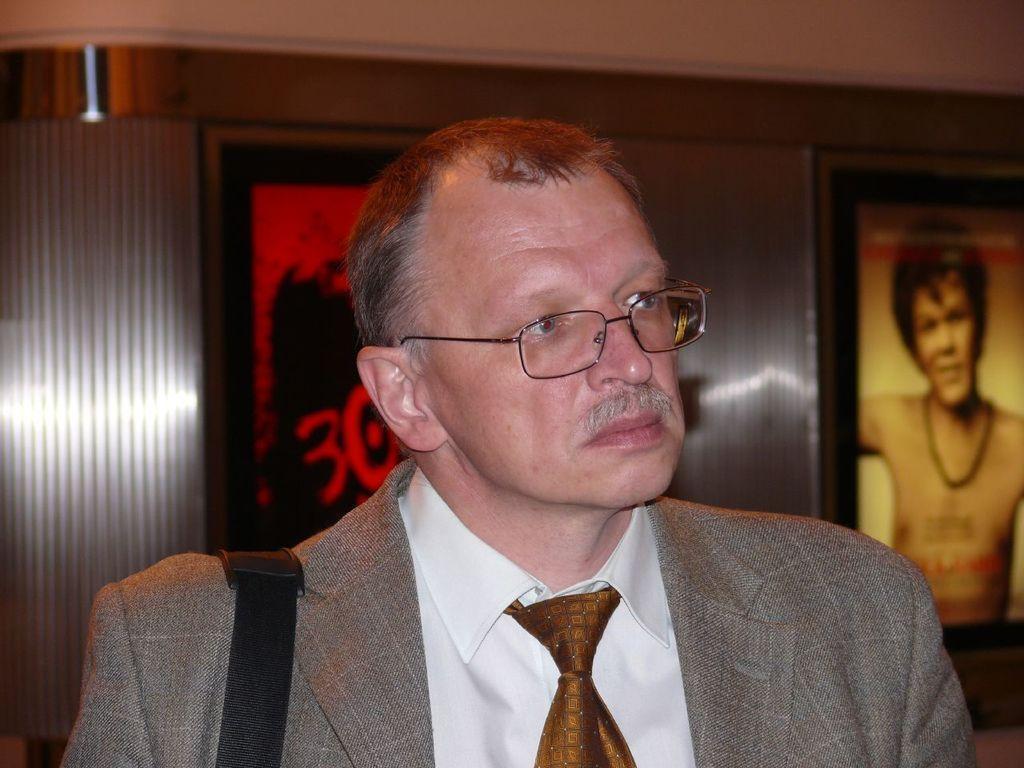Describe this image in one or two sentences. In this picture there is a man who is wearing spectacle and suit. In the back I can see the posts which are placed on the wall. On the right poster I can see the man who is the wearing a locket. On the left it might be the door. 